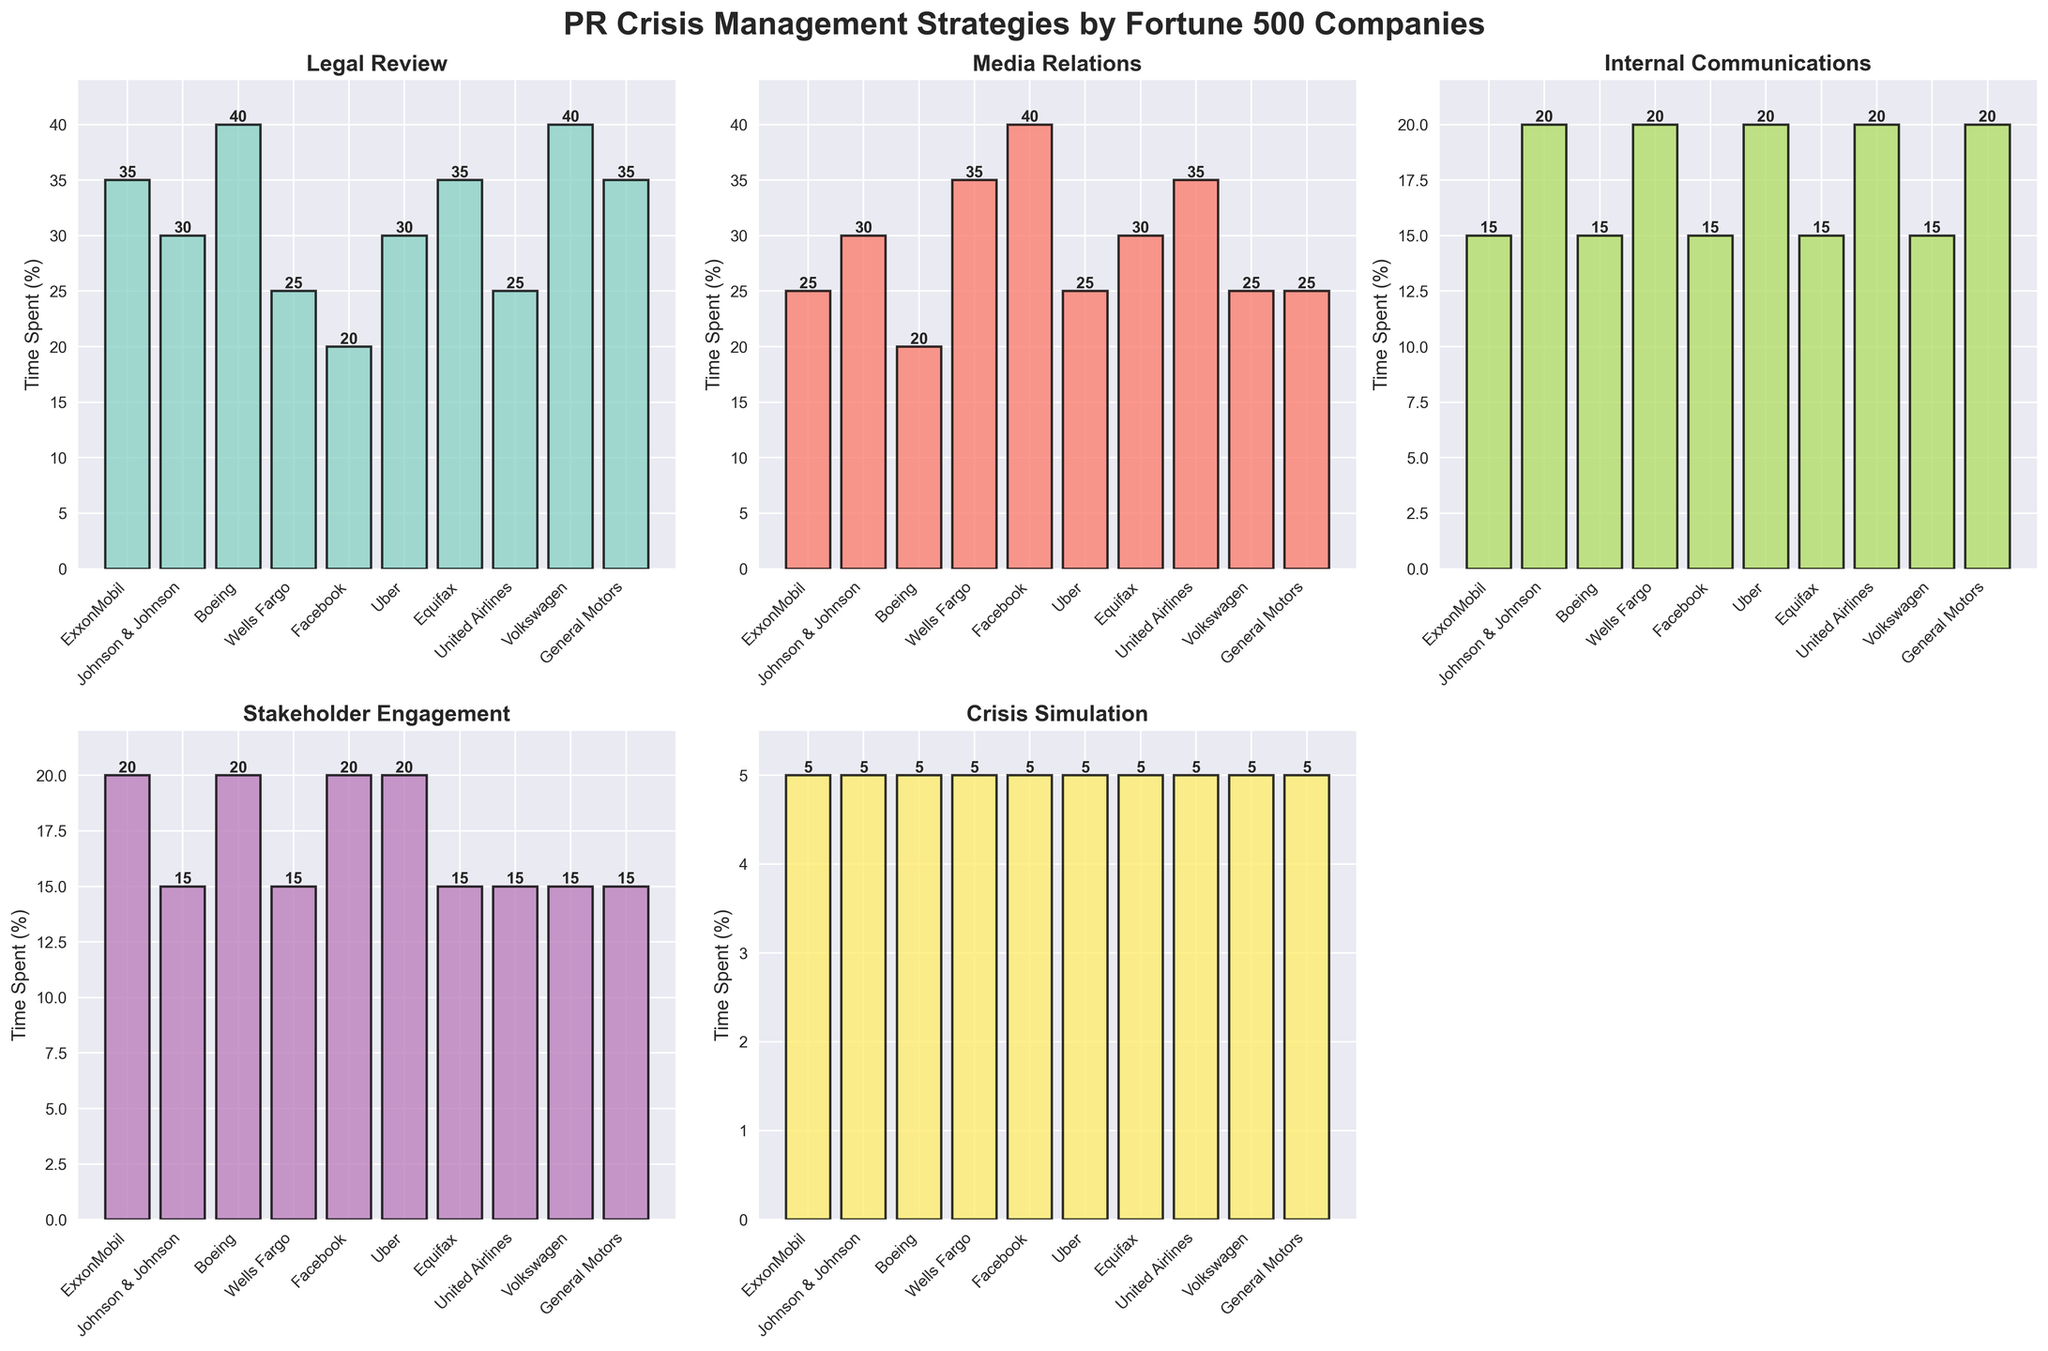Which company spends the most time on Legal Review? By reviewing the subplot for Legal Review, the bars represent each company's time spent on this strategy. The tallest bar corresponds to the highest value, which is for Boeing at 40%.
Answer: Boeing Which two companies spend the least time on Internal Communications? By looking at the Internal Communications subplot, identify the shortest bars. The two shortest bars, both at 15%, belong to ExxonMobil and Volkswagen
Answer: ExxonMobil and Volkswagen What is the total time Boeing spends on all strategies? Sum the values for Boeing across all strategies: 40 (Legal Review) + 20 (Media Relations) + 15 (Internal Communications) + 20 (Stakeholder Engagement) + 5 (Crisis Simulation) = 100%
Answer: 100% What is the average time spent on Media Relations by all companies? For Media Relations, sum all companies’ values and divide by the number of companies: (25 + 30 + 20 + 35 + 40 + 25 + 30 + 35 + 25 + 25) / 10 = 29%
Answer: 29% Which company spends more time on Stakeholder Engagement, Facebook or Uber? Compare the bar heights for Stakeholder Engagement for Facebook and Uber. Both have bars at the same height, which is 20%.
Answer: Both Which strategy has the most variation in the time spent across all companies? By inspecting the subplots, determine which strategy has the greatest range of bar heights. Legal Review ranges from 20% to 40%, showing the most variation among the strategies
Answer: Legal Review How much more time does Wells Fargo spend on Media Relations compared to Internal Communications? Find the values for Wells Fargo for Media Relations (35%) and Internal Communications (20%), then calculate the difference: 35% - 20% = 15%
Answer: 15% Which company spends the least time on Crisis Simulation, and how much do they spend? For Crisis Simulation, identify the company with the shortest bar, which is the same for all companies at 5%. Any company can be the answer; choose one.
Answer: ExxonMobil (5%) What is the median time spent on Legal Review by these companies? First, list the times spent by all companies on Legal Review: 40, 40, 35, 35, 35, 30, 30, 25, 25, 20. Arrange them in ascending order if not already: 20, 25, 25, 30, 30, 35, 35, 35, 40, 40. The middle values for an even number of data points are 30 and 35. The median is the average of these two: (30 + 35) / 2 = 32.5%
Answer: 32.5% Which company spends the highest amount of time on any single strategy, and what is that strategy? Scan through each subplot to find the highest single value, which is Media Relations for Facebook at 40%
Answer: Facebook (Media Relations) 